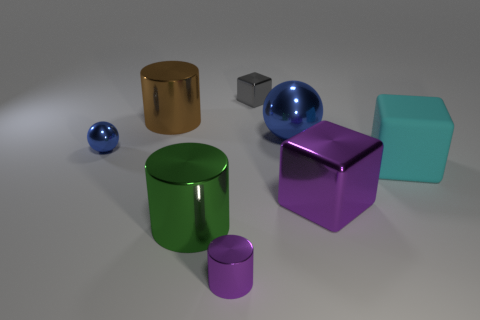Add 2 large brown metal things. How many objects exist? 10 Subtract all cylinders. How many objects are left? 5 Subtract 0 cyan cylinders. How many objects are left? 8 Subtract all big cyan things. Subtract all metallic blocks. How many objects are left? 5 Add 6 spheres. How many spheres are left? 8 Add 1 large purple things. How many large purple things exist? 2 